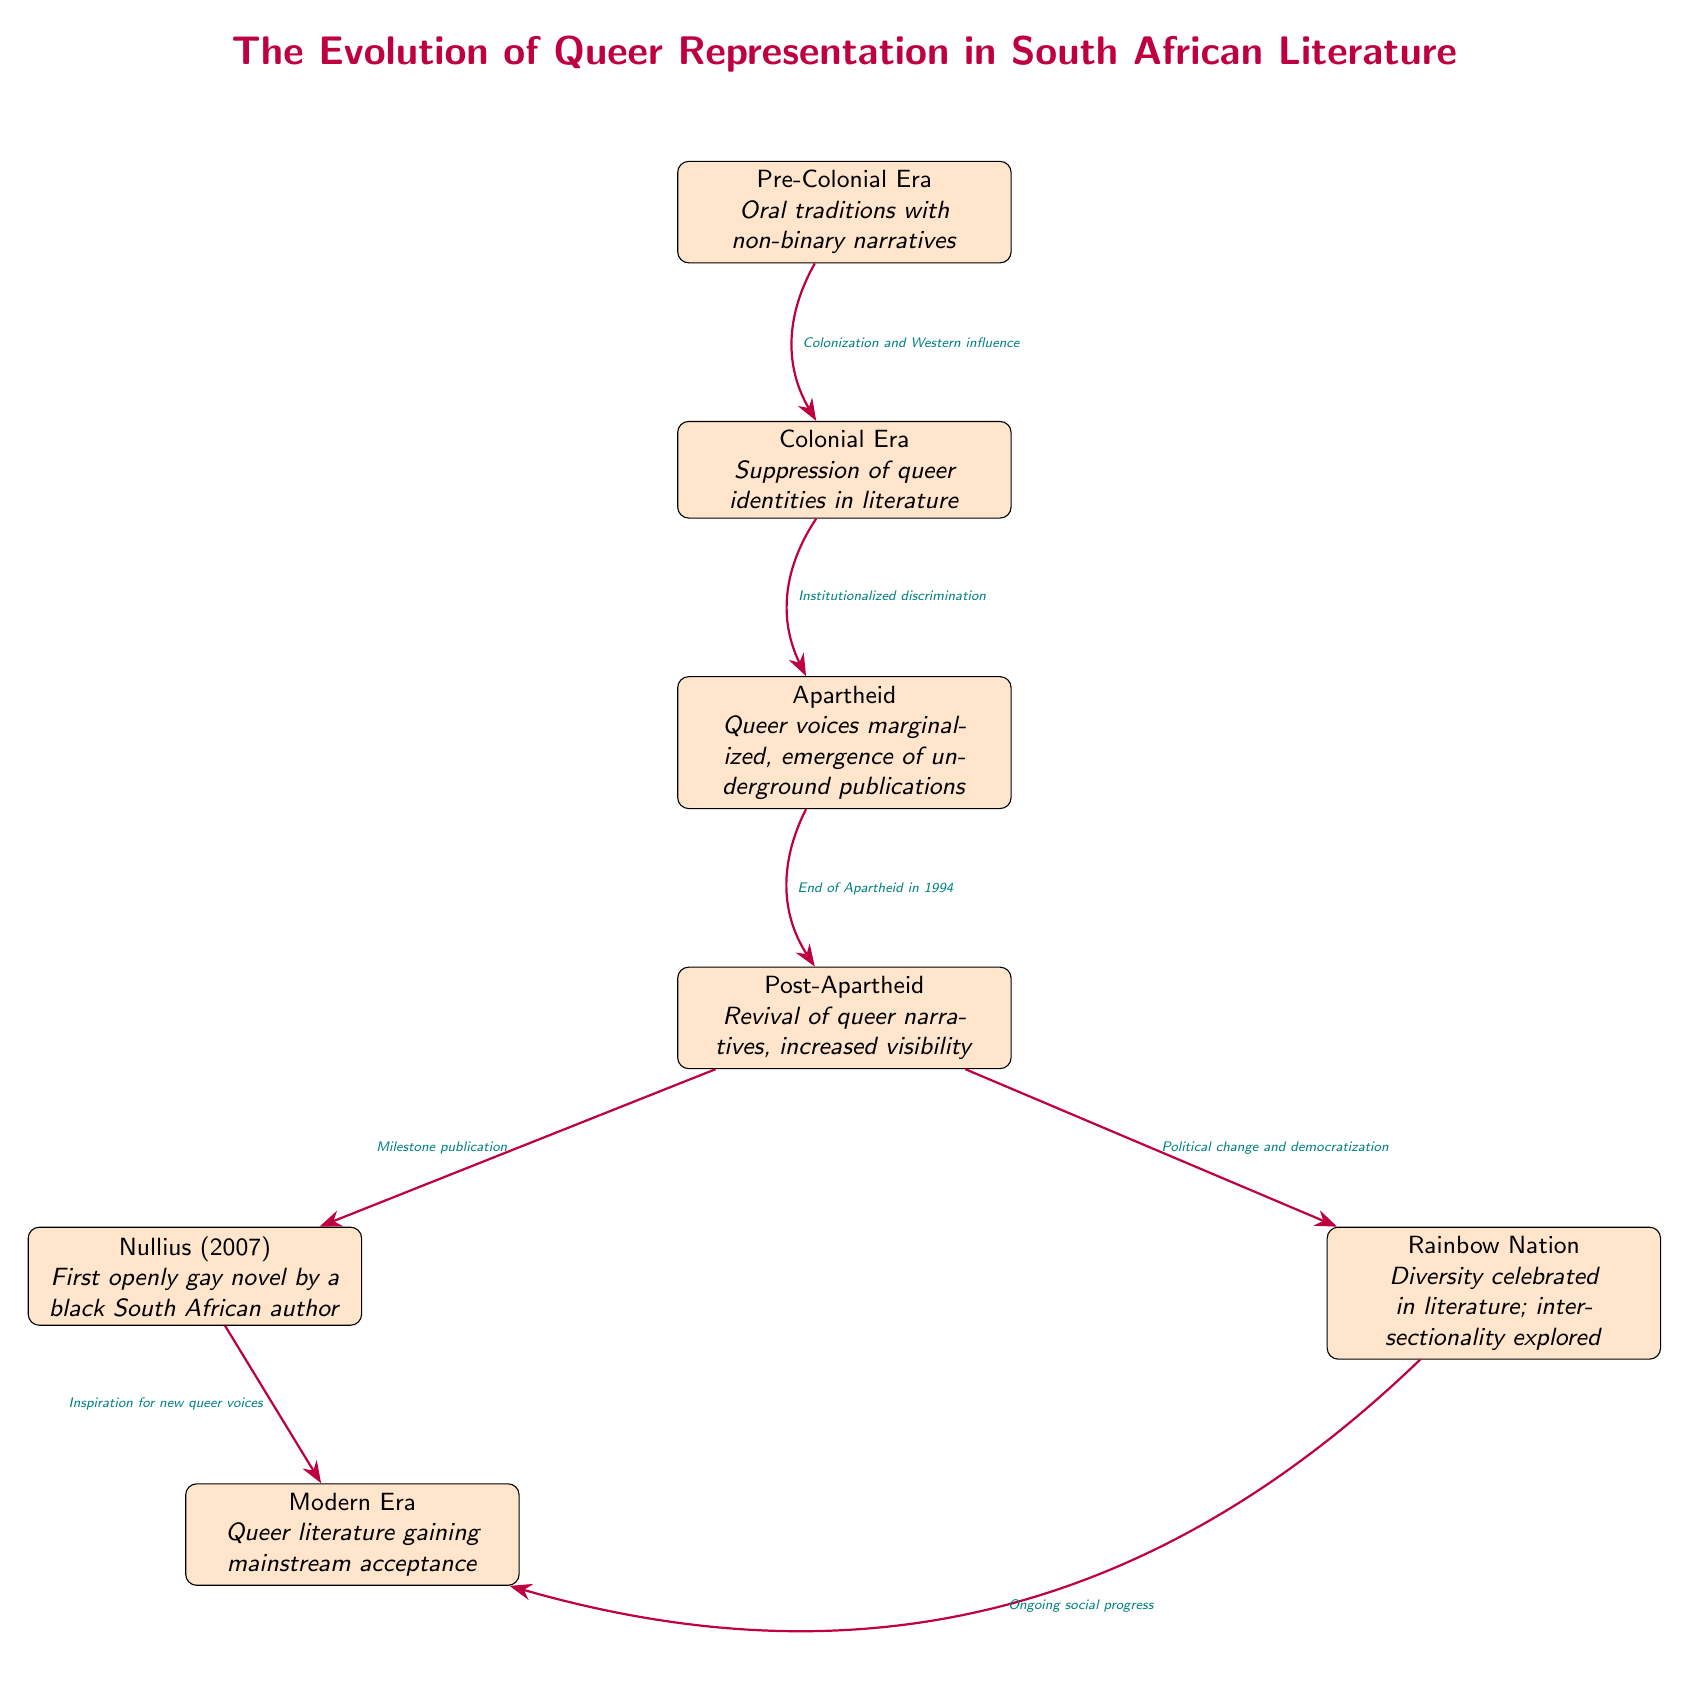What is the first era listed in the diagram? The diagram begins with the "Pre-Colonial Era" node, which is the topmost node.
Answer: Pre-Colonial Era How many main historical periods are represented in the diagram? By counting the nodes, we identify five main historical periods: Pre-Colonial Era, Colonial Era, Apartheid, Post-Apartheid, and Modern Era.
Answer: 5 What publication is considered the first openly gay novel by a black South African author? The diagram specifically names "Nullius (2007)" as the first openly gay novel by a black South African author.
Answer: Nullius (2007) What milestone is associated with the Post-Apartheid era in the diagram? The diagram indicates that the Post-Apartheid era had a milestone publication with "Nullius," showing its importance in queer literature.
Answer: Milestone publication What societal change is linked to the transition from Post-Apartheid to the Rainbow Nation? The move from Post-Apartheid to the Rainbow Nation is linked by the arrow labeled "Political change and democratization."
Answer: Political change and democratization Which node reflects the continued development of queer literature towards mainstream acceptance? The "Modern Era" node at the bottom of the diagram denotes the ongoing trend of queer literature gaining mainstream acceptance.
Answer: Modern Era What influence is depicted as contributing to the Colonial Era from the Pre-Colonial Era? The diagram shows an arrow with the label "Colonization and Western influence" indicating the impact from Pre-Colonial Era to Colonial Era.
Answer: Colonization and Western influence What is the relationship between the Rainbow Nation and the Modern Era? The diagram connects the Rainbow Nation to the Modern Era through an arrow labeled "Ongoing social progress," indicating an evolution in narrative acceptance.
Answer: Ongoing social progress What distinguishes the Apartheid era in the context of queer literature? The diagram highlights that during the Apartheid era, queer voices were marginalized, and this is a distinguishing feature of this period in literature.
Answer: Queer voices marginalized What does the term "intersectionality" refer to in the context of the Rainbow Nation? The diagram suggests that during the Rainbow Nation period, there was a celebration of diversity in literature, implying that intersectionality is an exploration of multiple identities.
Answer: Intersectionality explored 